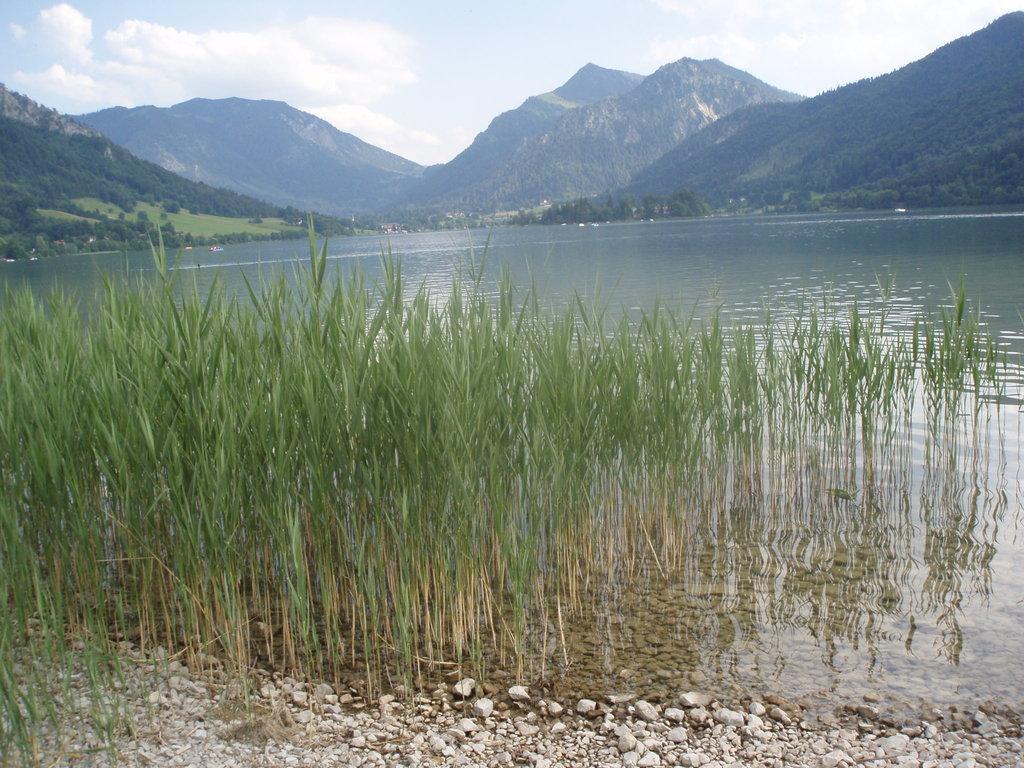Could you give a brief overview of what you see in this image? There are stones and water. Also there are plants. In the back there are hills and sky with clouds. 